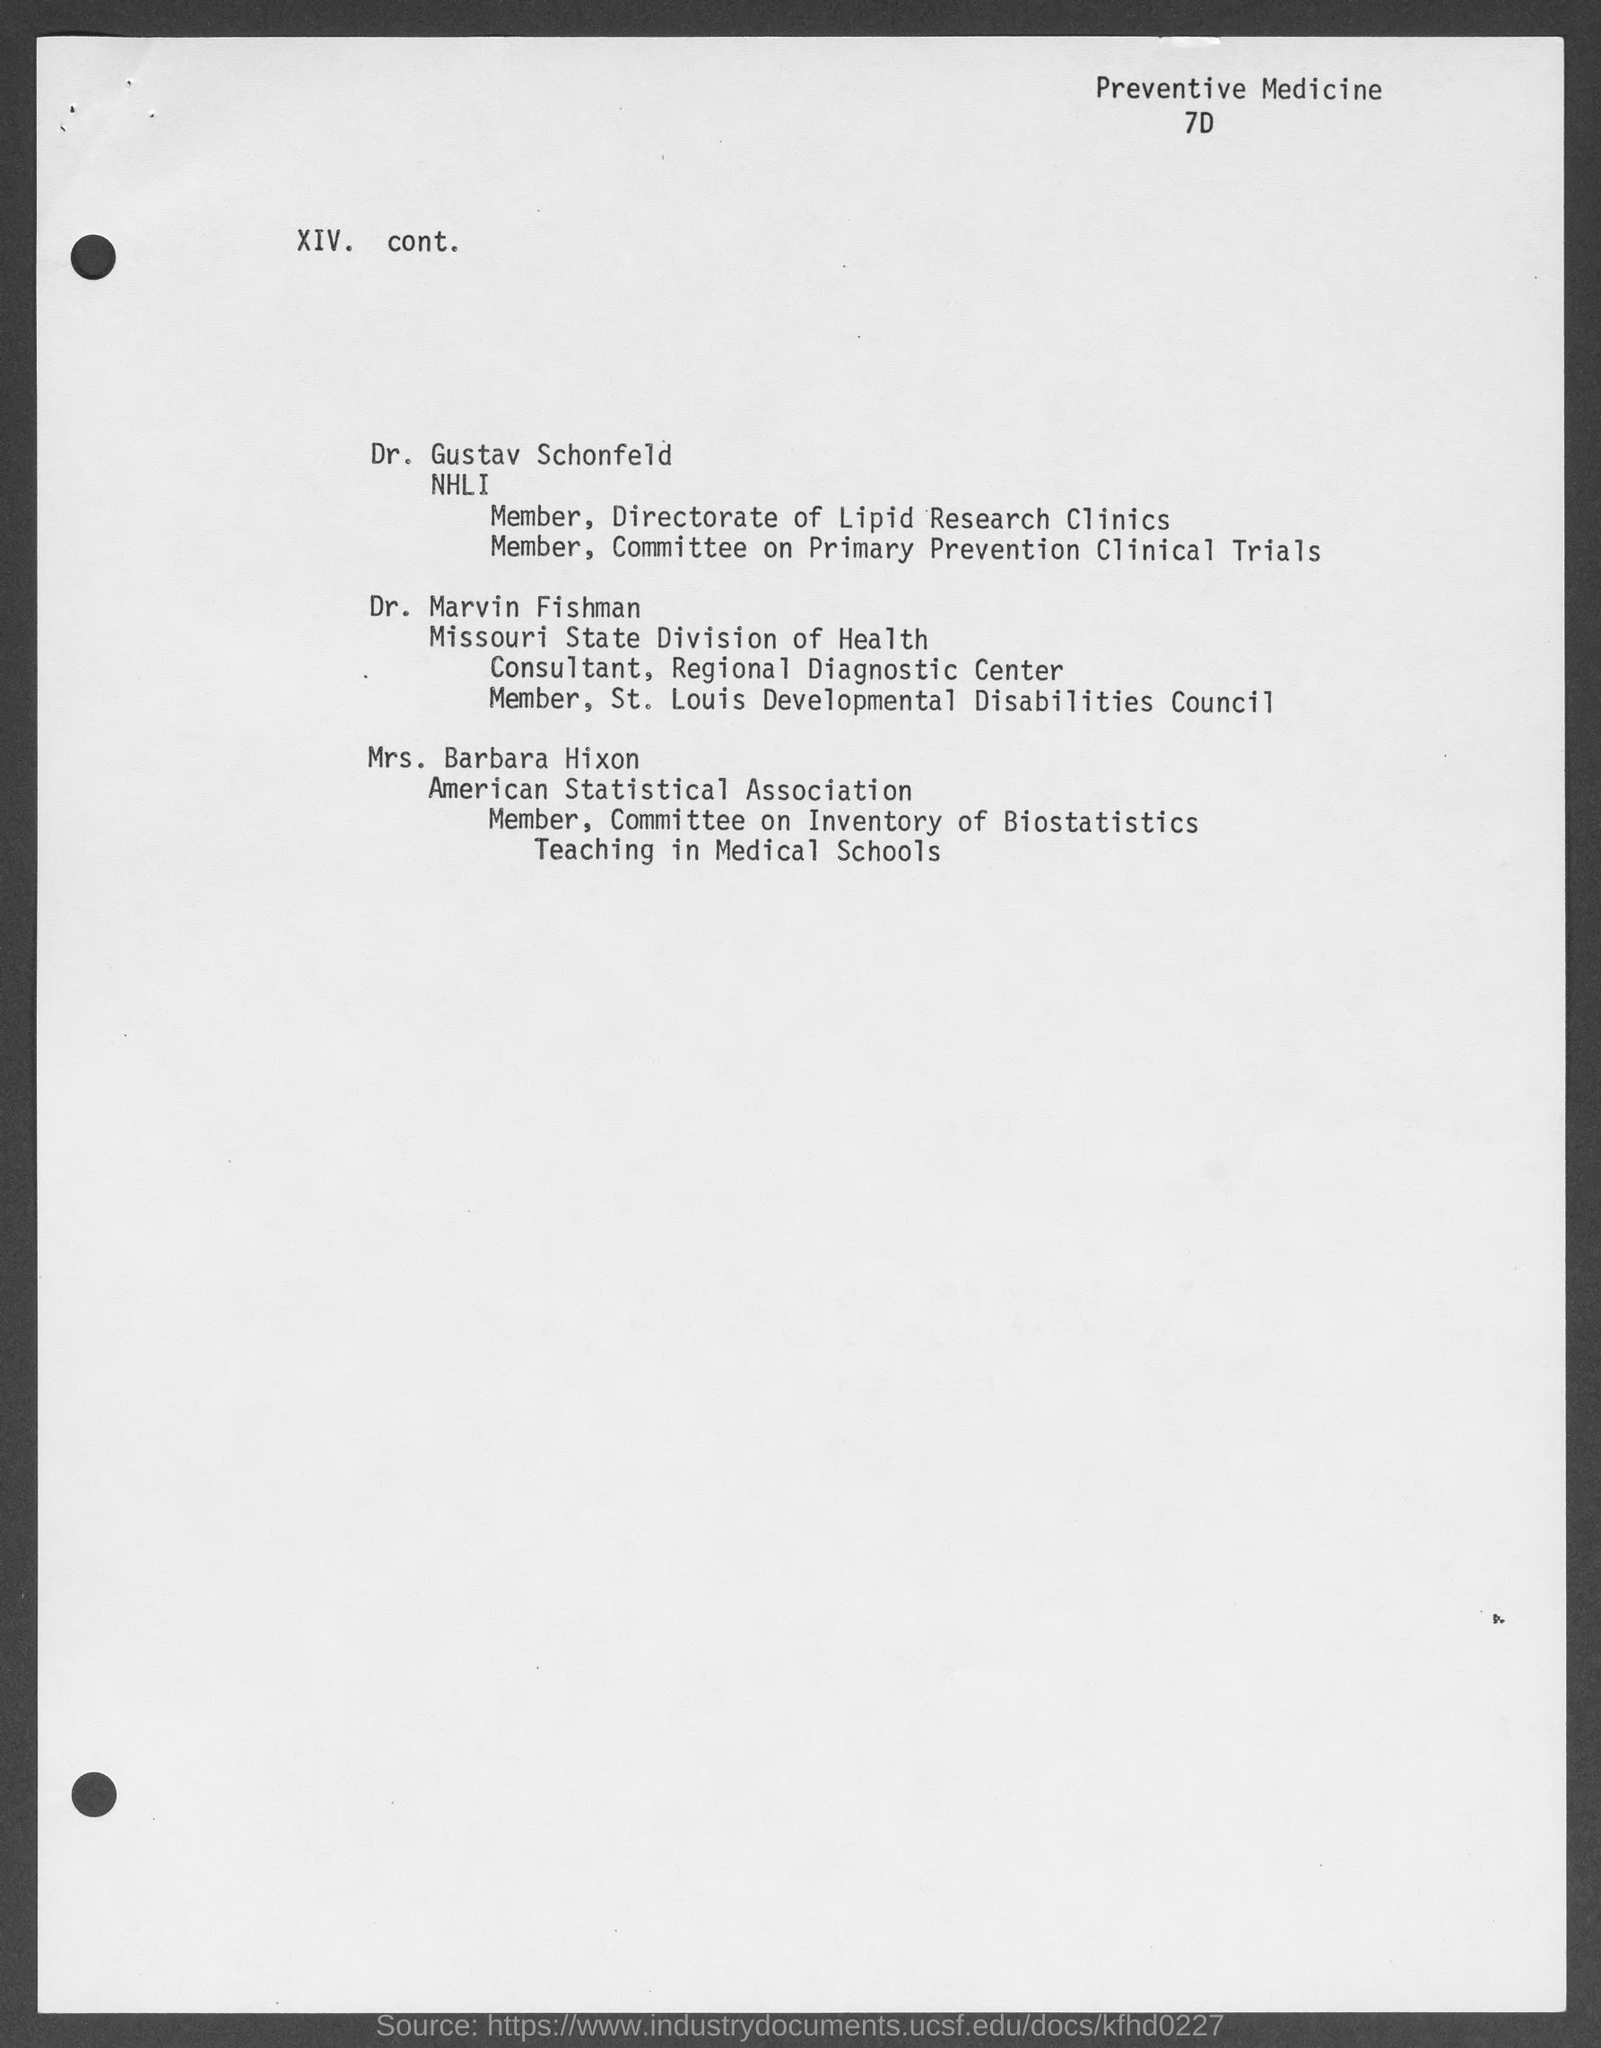To which association does mrs. barbara hixon belong?
Your answer should be compact. American Statistical Association. 